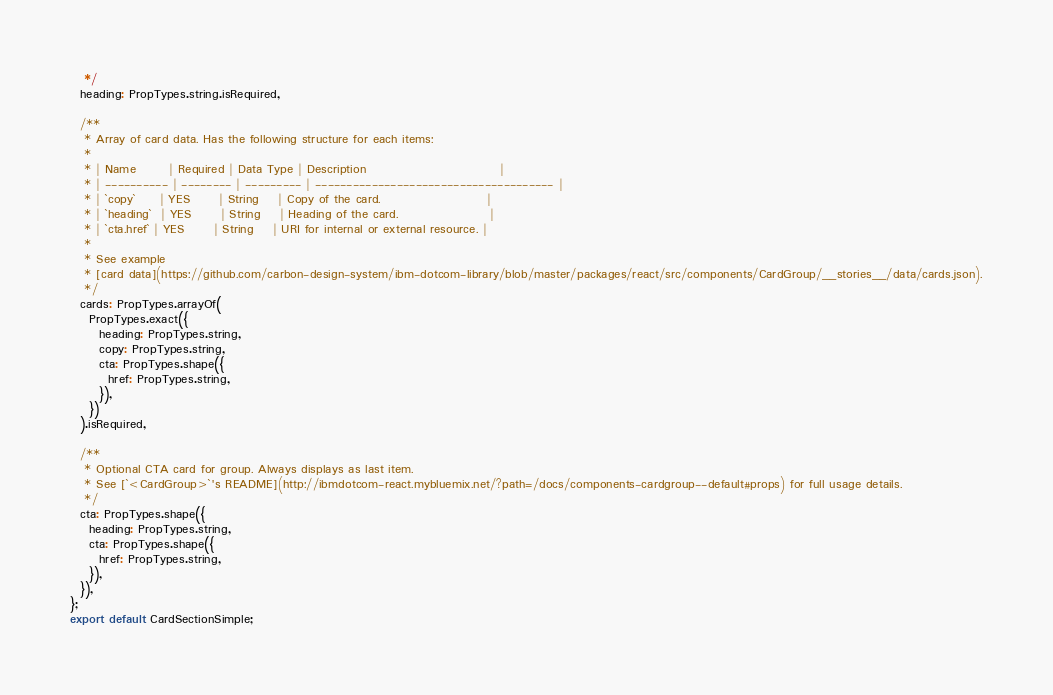<code> <loc_0><loc_0><loc_500><loc_500><_JavaScript_>   */
  heading: PropTypes.string.isRequired,

  /**
   * Array of card data. Has the following structure for each items:
   *
   * | Name       | Required | Data Type | Description                            |
   * | ---------- | -------- | --------- | -------------------------------------- |
   * | `copy`     | YES      | String    | Copy of the card.                      |
   * | `heading`  | YES      | String    | Heading of the card.                   |
   * | `cta.href` | YES      | String    | URI for internal or external resource. |
   *
   * See example
   * [card data](https://github.com/carbon-design-system/ibm-dotcom-library/blob/master/packages/react/src/components/CardGroup/__stories__/data/cards.json).
   */
  cards: PropTypes.arrayOf(
    PropTypes.exact({
      heading: PropTypes.string,
      copy: PropTypes.string,
      cta: PropTypes.shape({
        href: PropTypes.string,
      }),
    })
  ).isRequired,

  /**
   * Optional CTA card for group. Always displays as last item.
   * See [`<CardGroup>`'s README](http://ibmdotcom-react.mybluemix.net/?path=/docs/components-cardgroup--default#props) for full usage details.
   */
  cta: PropTypes.shape({
    heading: PropTypes.string,
    cta: PropTypes.shape({
      href: PropTypes.string,
    }),
  }),
};
export default CardSectionSimple;
</code> 